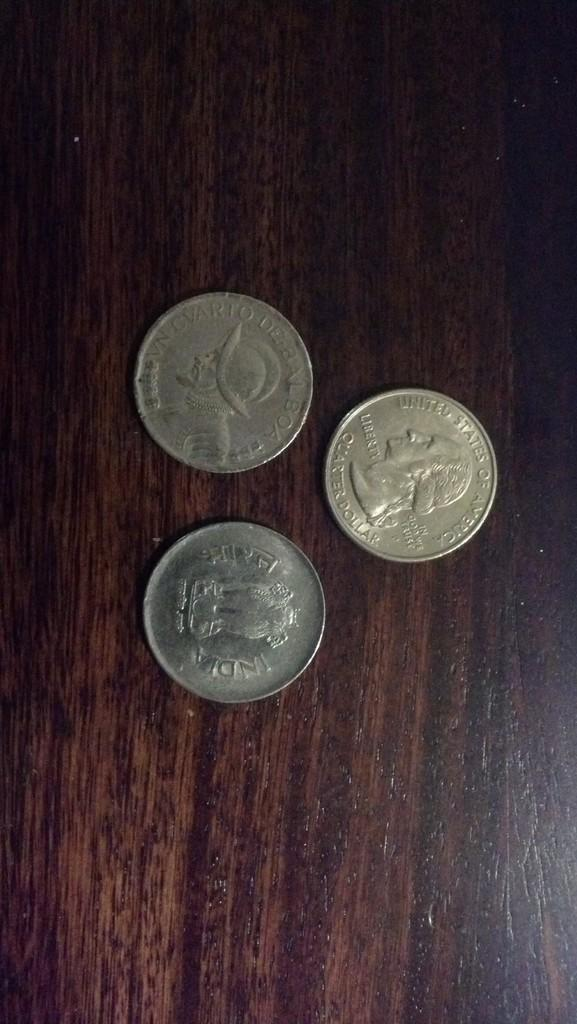Provide a one-sentence caption for the provided image. Three coins sit on a desk and one of them says United States of America. 